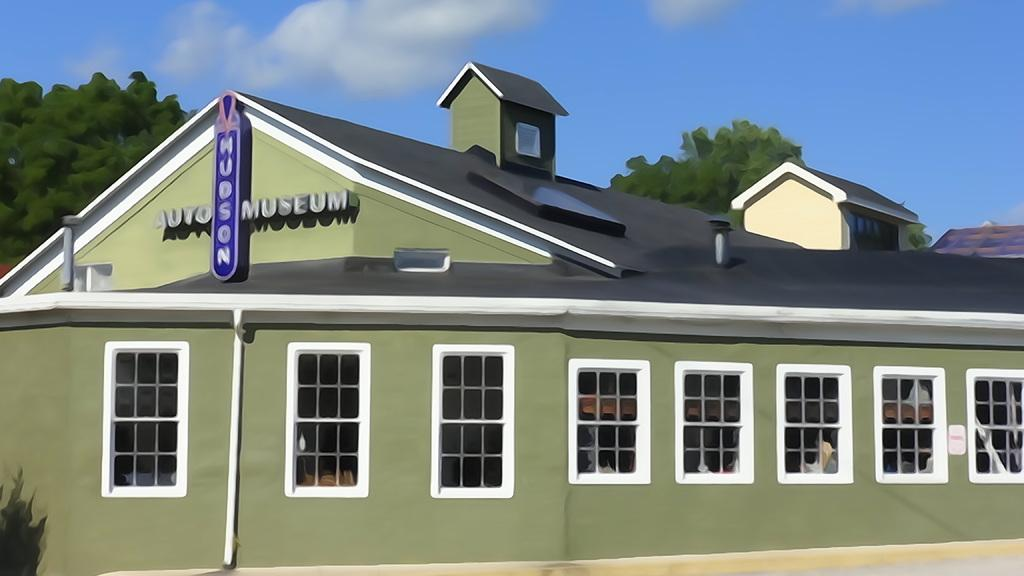What type of house is depicted in the picture? There is an animated house in the picture. What features can be seen on the house? The house has windows. What can be seen in the background of the picture? Trees are visible in the background of the picture. What is visible in the sky? Clouds are present in the sky. Can you tell me how many porters are standing near the animated house in the image? There are no porters present in the image; it features an animated house with no additional characters or figures. What type of twig can be seen growing on the animated house in the image? There is no twig visible on the animated house in the image. 